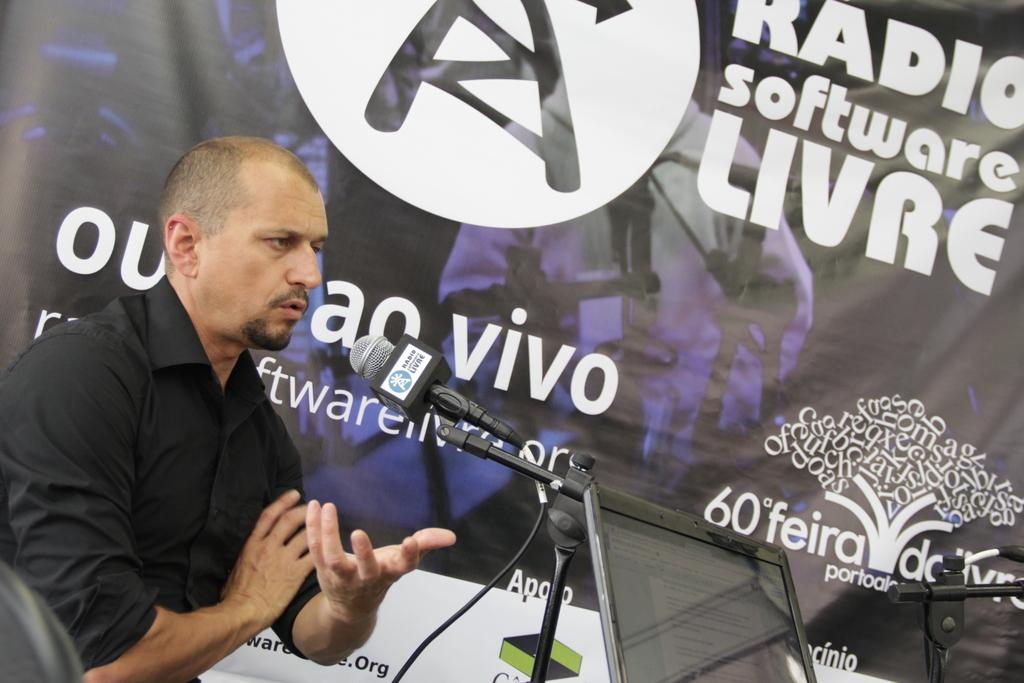What can be seen in the background of the image? There is a hoarding in the background of the image. What is the man wearing in the image? The man is wearing a black shirt in the image. What object is present in the image that is typically used for amplifying sound? There is a microphone with a stand in the image. What type of store is visible in the image? There is no store visible in the image. What selection of classes is being offered in the image? There is no mention of classes or a selection of classes in the image. 